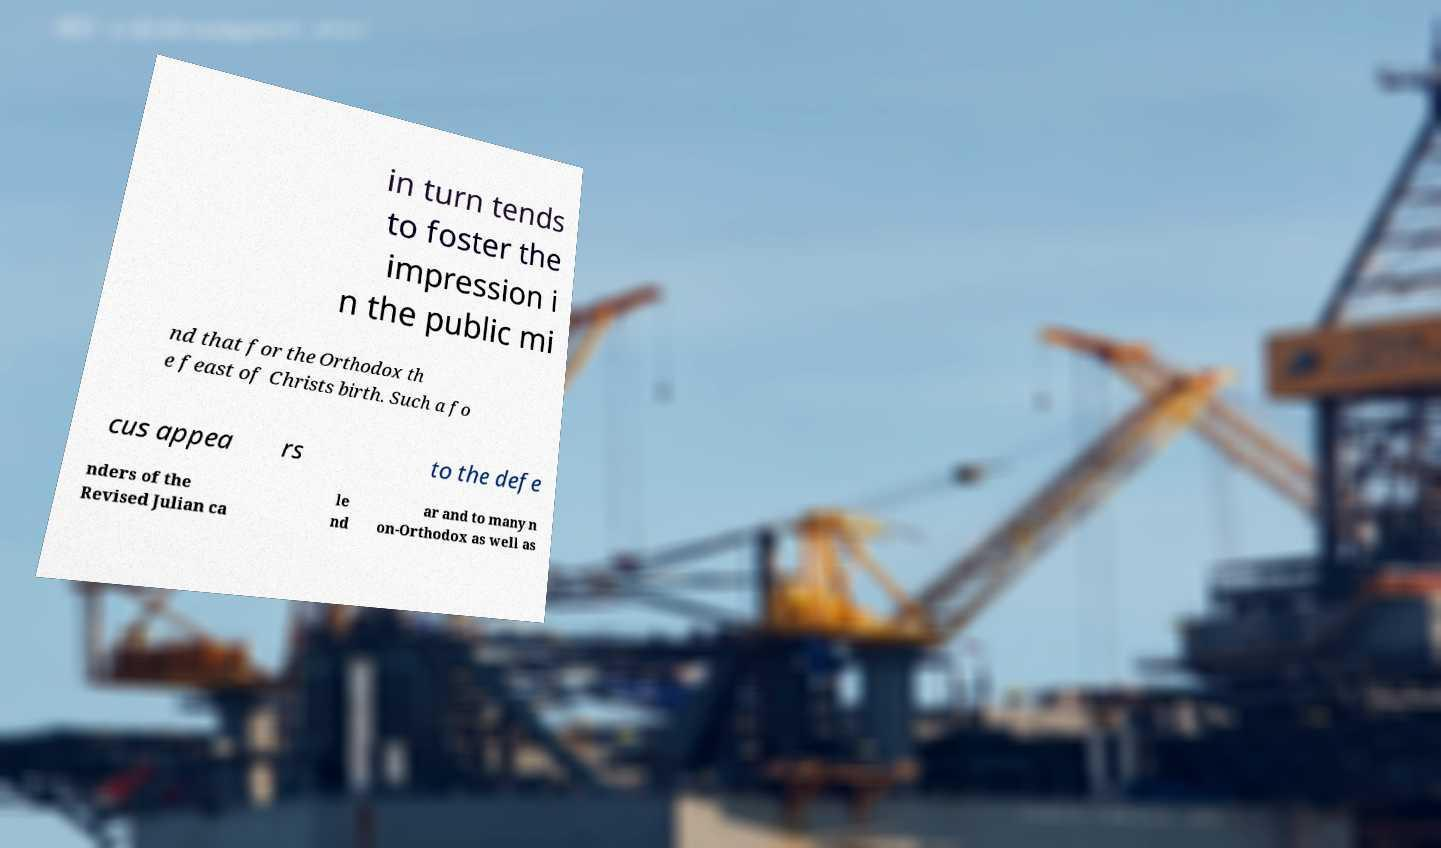What messages or text are displayed in this image? I need them in a readable, typed format. in turn tends to foster the impression i n the public mi nd that for the Orthodox th e feast of Christs birth. Such a fo cus appea rs to the defe nders of the Revised Julian ca le nd ar and to many n on-Orthodox as well as 